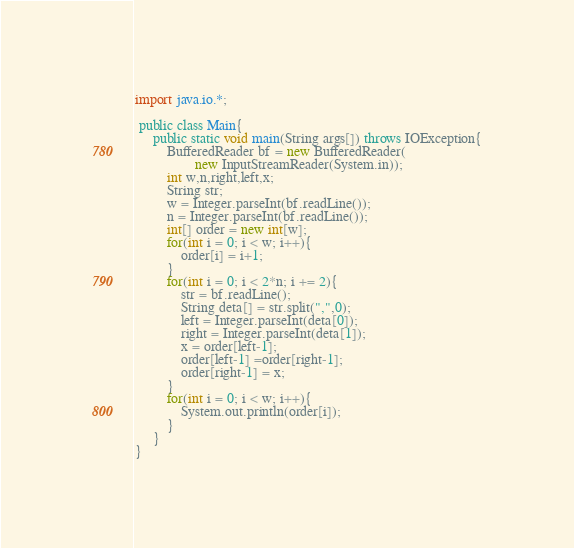<code> <loc_0><loc_0><loc_500><loc_500><_Java_>import java.io.*;

 public class Main{
	 public static void main(String args[]) throws IOException{
		 BufferedReader bf = new BufferedReader(
				 new InputStreamReader(System.in));
		 int w,n,right,left,x;
		 String str;
		 w = Integer.parseInt(bf.readLine());
		 n = Integer.parseInt(bf.readLine());
		 int[] order = new int[w];
		 for(int i = 0; i < w; i++){
			 order[i] = i+1;
		 }
		 for(int i = 0; i < 2*n; i += 2){
			 str = bf.readLine();
			 String deta[] = str.split(",",0);
			 left = Integer.parseInt(deta[0]);
			 right = Integer.parseInt(deta[1]);
			 x = order[left-1];
			 order[left-1] =order[right-1];
			 order[right-1] = x;
		 }
		 for(int i = 0; i < w; i++){
			 System.out.println(order[i]);
		 }
	 }
}</code> 